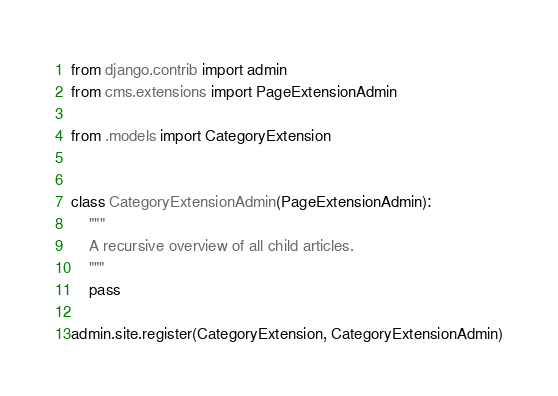Convert code to text. <code><loc_0><loc_0><loc_500><loc_500><_Python_>from django.contrib import admin
from cms.extensions import PageExtensionAdmin

from .models import CategoryExtension


class CategoryExtensionAdmin(PageExtensionAdmin):
    """
    A recursive overview of all child articles.
    """
    pass

admin.site.register(CategoryExtension, CategoryExtensionAdmin)
</code> 